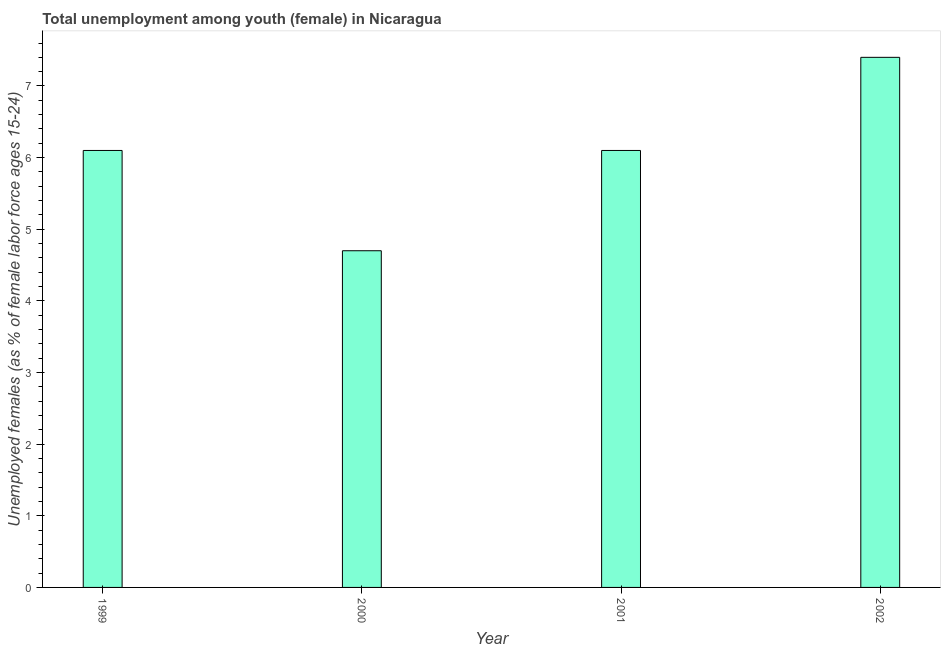Does the graph contain any zero values?
Ensure brevity in your answer.  No. What is the title of the graph?
Provide a succinct answer. Total unemployment among youth (female) in Nicaragua. What is the label or title of the X-axis?
Your answer should be compact. Year. What is the label or title of the Y-axis?
Provide a succinct answer. Unemployed females (as % of female labor force ages 15-24). What is the unemployed female youth population in 2001?
Offer a terse response. 6.1. Across all years, what is the maximum unemployed female youth population?
Provide a short and direct response. 7.4. Across all years, what is the minimum unemployed female youth population?
Make the answer very short. 4.7. In which year was the unemployed female youth population minimum?
Offer a very short reply. 2000. What is the sum of the unemployed female youth population?
Provide a succinct answer. 24.3. What is the difference between the unemployed female youth population in 2000 and 2002?
Your response must be concise. -2.7. What is the average unemployed female youth population per year?
Your answer should be compact. 6.08. What is the median unemployed female youth population?
Your answer should be very brief. 6.1. In how many years, is the unemployed female youth population greater than 6.8 %?
Your response must be concise. 1. What is the ratio of the unemployed female youth population in 2000 to that in 2001?
Give a very brief answer. 0.77. Is the unemployed female youth population in 1999 less than that in 2000?
Provide a short and direct response. No. What is the difference between the highest and the second highest unemployed female youth population?
Make the answer very short. 1.3. How many years are there in the graph?
Your response must be concise. 4. Are the values on the major ticks of Y-axis written in scientific E-notation?
Offer a terse response. No. What is the Unemployed females (as % of female labor force ages 15-24) in 1999?
Your response must be concise. 6.1. What is the Unemployed females (as % of female labor force ages 15-24) in 2000?
Provide a short and direct response. 4.7. What is the Unemployed females (as % of female labor force ages 15-24) in 2001?
Keep it short and to the point. 6.1. What is the Unemployed females (as % of female labor force ages 15-24) of 2002?
Offer a terse response. 7.4. What is the difference between the Unemployed females (as % of female labor force ages 15-24) in 1999 and 2001?
Ensure brevity in your answer.  0. What is the difference between the Unemployed females (as % of female labor force ages 15-24) in 2000 and 2002?
Your response must be concise. -2.7. What is the difference between the Unemployed females (as % of female labor force ages 15-24) in 2001 and 2002?
Your answer should be very brief. -1.3. What is the ratio of the Unemployed females (as % of female labor force ages 15-24) in 1999 to that in 2000?
Provide a succinct answer. 1.3. What is the ratio of the Unemployed females (as % of female labor force ages 15-24) in 1999 to that in 2002?
Make the answer very short. 0.82. What is the ratio of the Unemployed females (as % of female labor force ages 15-24) in 2000 to that in 2001?
Provide a short and direct response. 0.77. What is the ratio of the Unemployed females (as % of female labor force ages 15-24) in 2000 to that in 2002?
Give a very brief answer. 0.64. What is the ratio of the Unemployed females (as % of female labor force ages 15-24) in 2001 to that in 2002?
Keep it short and to the point. 0.82. 